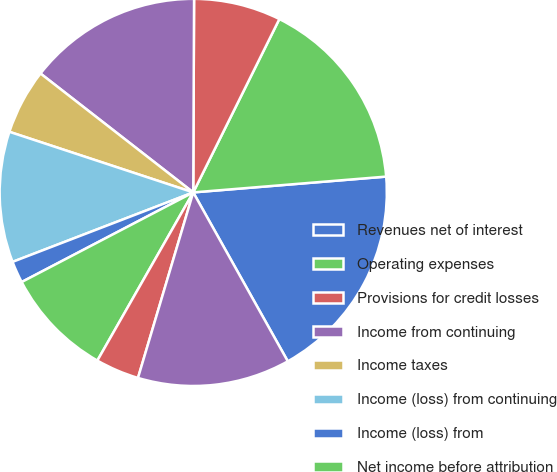<chart> <loc_0><loc_0><loc_500><loc_500><pie_chart><fcel>Revenues net of interest<fcel>Operating expenses<fcel>Provisions for credit losses<fcel>Income from continuing<fcel>Income taxes<fcel>Income (loss) from continuing<fcel>Income (loss) from<fcel>Net income before attribution<fcel>Noncontrolling interests<fcel>Citigroup's net income (loss)<nl><fcel>18.18%<fcel>16.36%<fcel>7.27%<fcel>14.54%<fcel>5.46%<fcel>10.91%<fcel>1.82%<fcel>9.09%<fcel>3.64%<fcel>12.73%<nl></chart> 